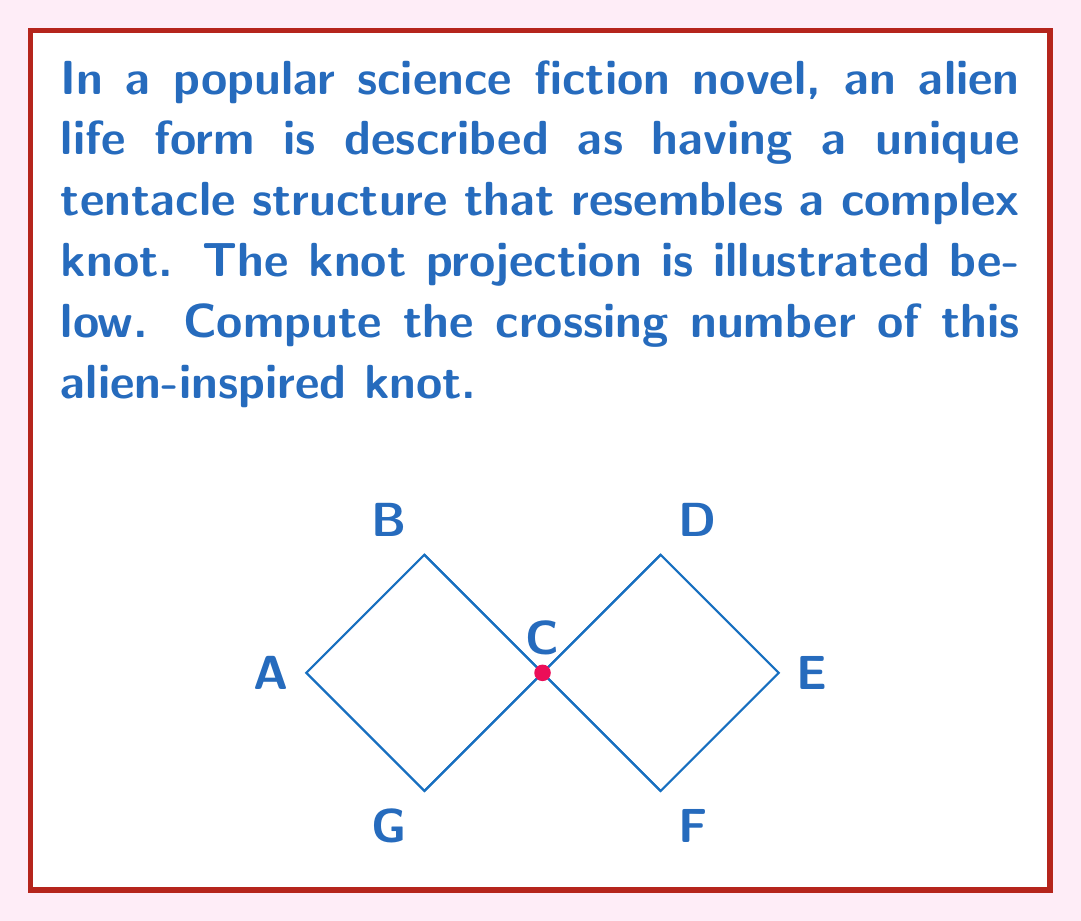Show me your answer to this math problem. To compute the crossing number of this alien-inspired knot, we need to follow these steps:

1) First, let's identify all the crossings in the given knot projection:
   - There is a crossing at point C (center)
   - There are two additional crossings where the diagonal lines intersect the outer loop

2) Count the total number of crossings:
   $$\text{Total crossings} = 1 + 2 = 3$$

3) The crossing number of a knot is defined as the minimum number of crossings in any projection of the knot. Therefore, we need to consider if this projection has the minimum number of crossings possible for this knot.

4) Observe that this knot projection resembles a trefoil knot, which is known to have a crossing number of 3.

5) To confirm this is indeed a trefoil knot, we can trace the path:
   A → B → C → D → E → F → C → G → A
   This path creates three lobes characteristic of a trefoil knot.

6) The trefoil knot is a prime knot, meaning it cannot be simplified further without cutting and rejoining the strand.

7) Therefore, this projection already shows the minimum number of crossings possible for this knot.

Thus, the crossing number of this alien-inspired knot is 3.
Answer: 3 